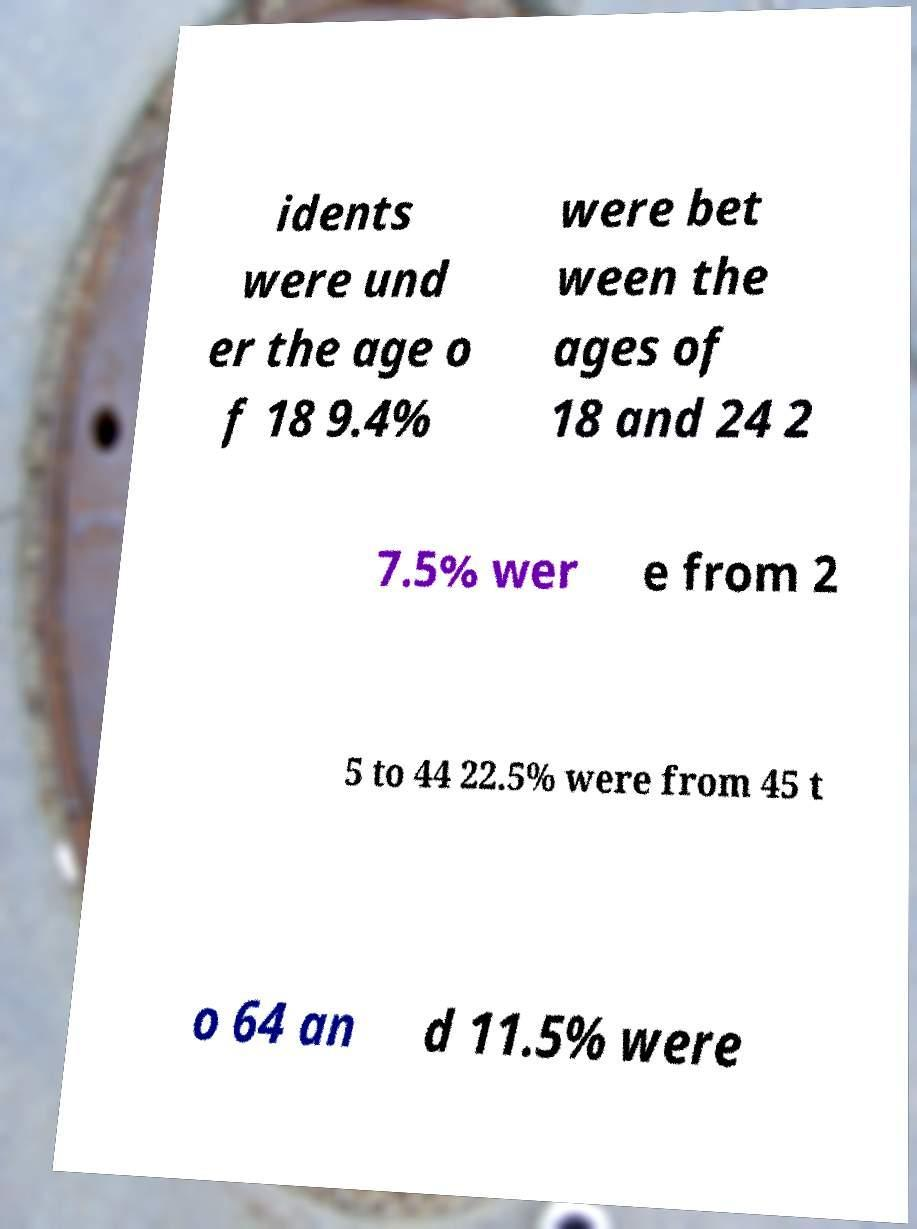I need the written content from this picture converted into text. Can you do that? idents were und er the age o f 18 9.4% were bet ween the ages of 18 and 24 2 7.5% wer e from 2 5 to 44 22.5% were from 45 t o 64 an d 11.5% were 